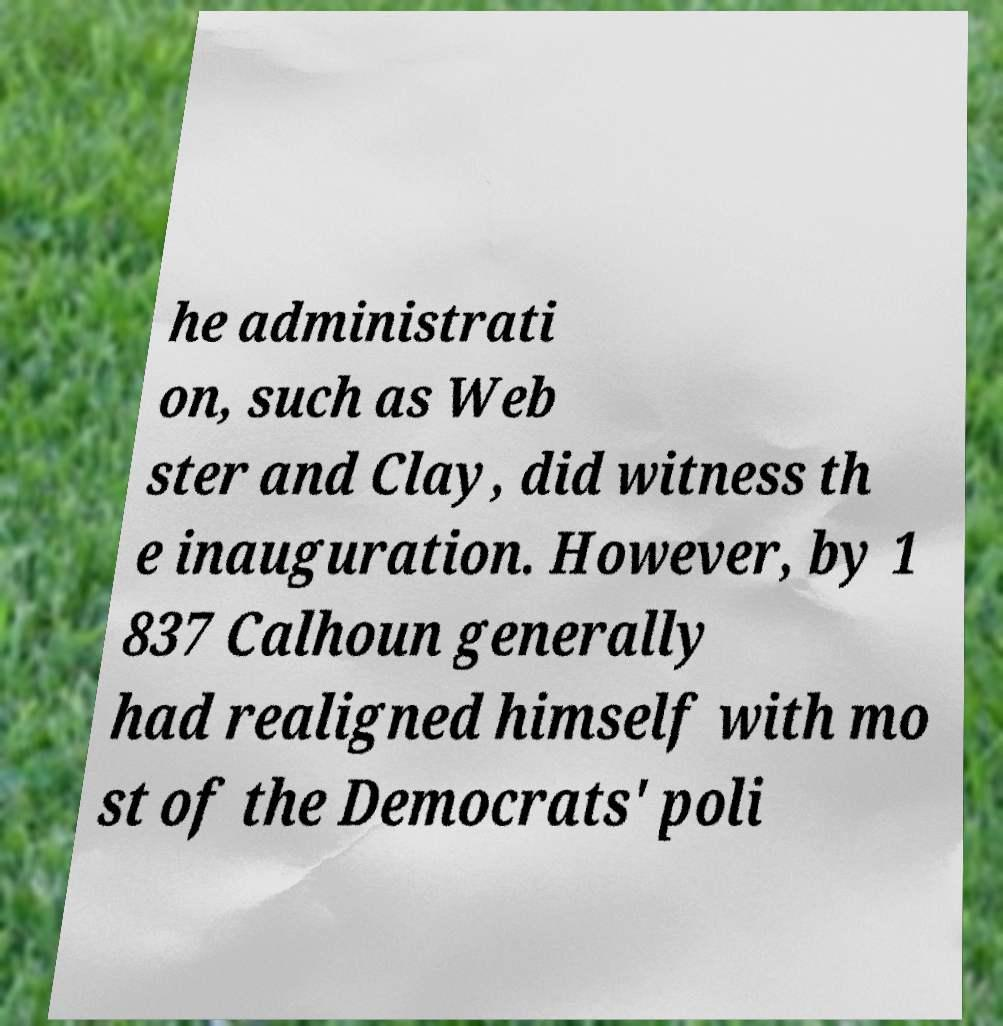What messages or text are displayed in this image? I need them in a readable, typed format. he administrati on, such as Web ster and Clay, did witness th e inauguration. However, by 1 837 Calhoun generally had realigned himself with mo st of the Democrats' poli 